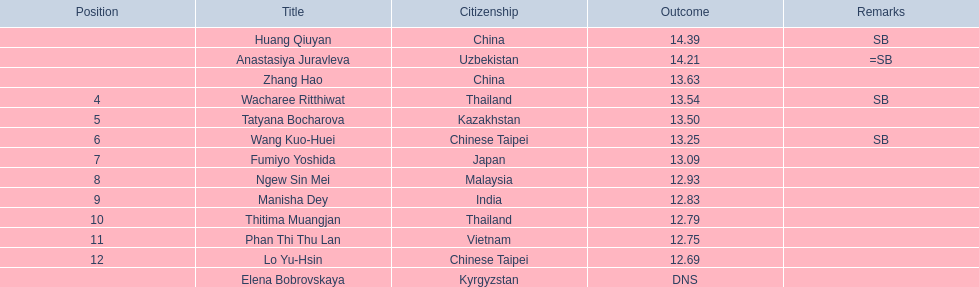How many athletes were from china? 2. 